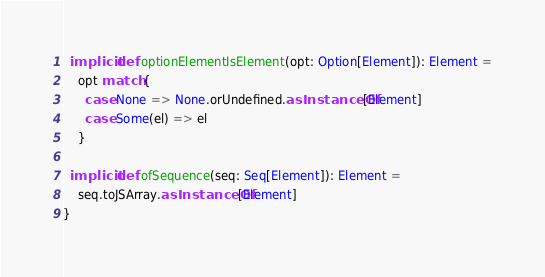<code> <loc_0><loc_0><loc_500><loc_500><_Scala_>
  implicit def optionElementIsElement(opt: Option[Element]): Element =
    opt match {
      case None => None.orUndefined.asInstanceOf[Element]
      case Some(el) => el
    }

  implicit def ofSequence(seq: Seq[Element]): Element =
    seq.toJSArray.asInstanceOf[Element]
}
</code> 